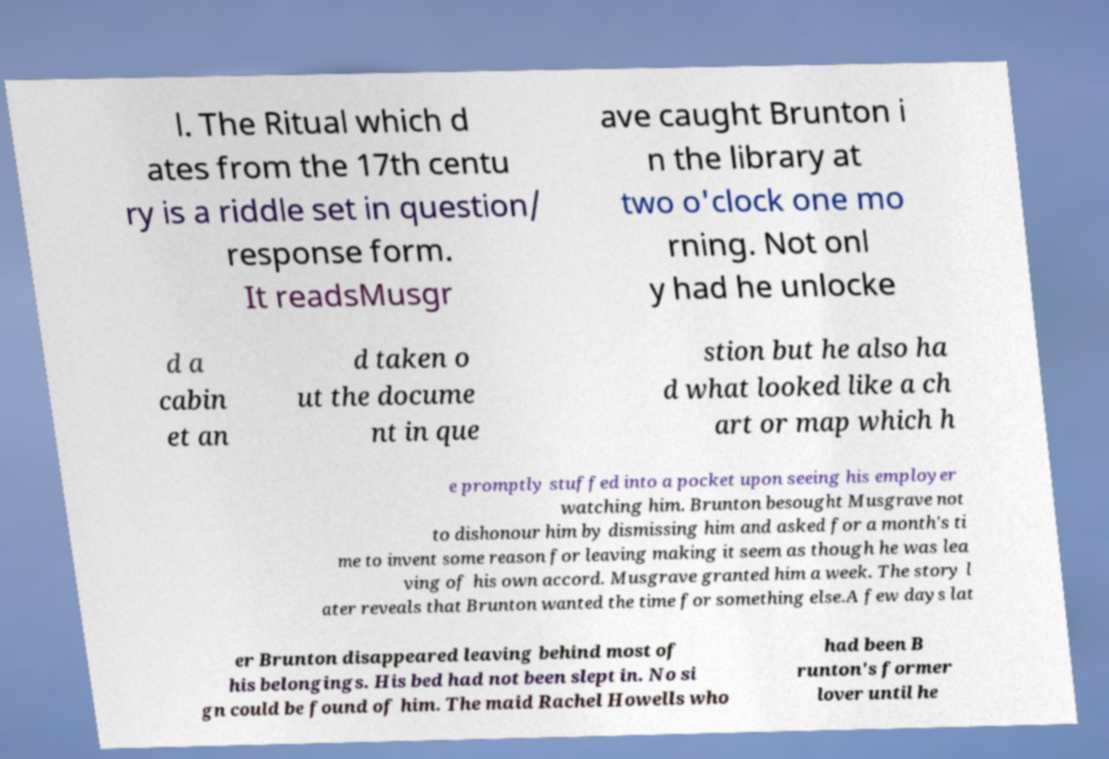There's text embedded in this image that I need extracted. Can you transcribe it verbatim? l. The Ritual which d ates from the 17th centu ry is a riddle set in question/ response form. It readsMusgr ave caught Brunton i n the library at two o'clock one mo rning. Not onl y had he unlocke d a cabin et an d taken o ut the docume nt in que stion but he also ha d what looked like a ch art or map which h e promptly stuffed into a pocket upon seeing his employer watching him. Brunton besought Musgrave not to dishonour him by dismissing him and asked for a month's ti me to invent some reason for leaving making it seem as though he was lea ving of his own accord. Musgrave granted him a week. The story l ater reveals that Brunton wanted the time for something else.A few days lat er Brunton disappeared leaving behind most of his belongings. His bed had not been slept in. No si gn could be found of him. The maid Rachel Howells who had been B runton's former lover until he 